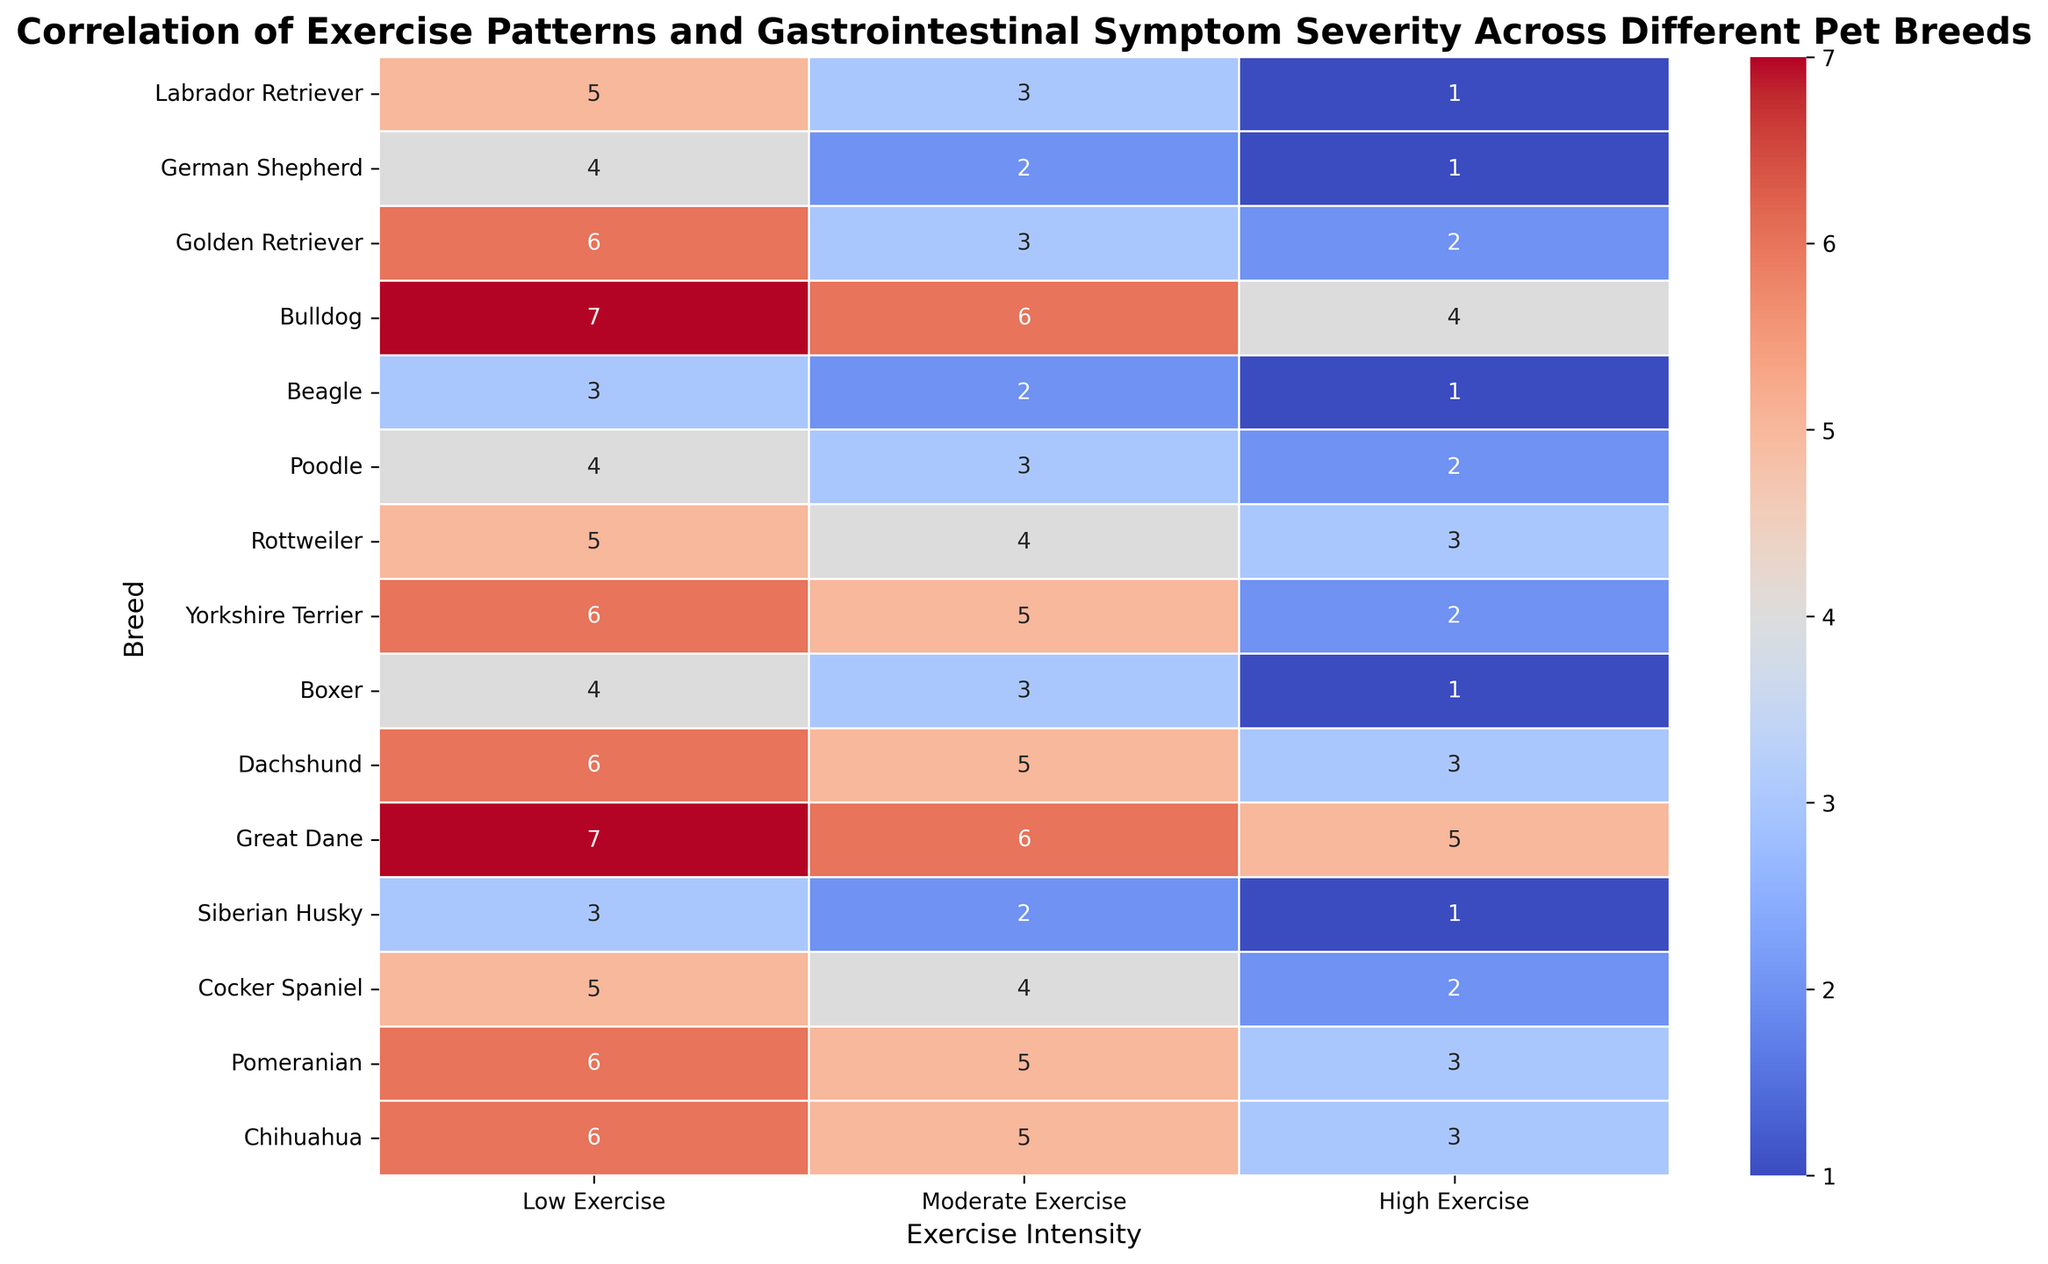What breed shows the highest severity of gastrointestinal symptoms in low exercise? In the heatmap, check the Low Exercise column. The breed with the highest value in this column is Bulldog with a value of 7.
Answer: Bulldog Which breed experiences the greatest reduction in symptoms from low to high exercise? Compute the differences for each breed: Labrador Retriever (5-1=4), German Shepherd (4-1=3), Golden Retriever (6-2=4), Bulldog (7-4=3), Beagle (3-1=2), Poodle (4-2=2), Rottweiler (5-3=2), Yorkshire Terrier (6-2=4), Boxer (4-1=3), Dachshund (6-3=3), Great Dane (7-5=2), Siberian Husky (3-1=2), Cocker Spaniel (5-2=3), Pomeranian (6-3=3), Chihuahua (6-3=3). The largest reduction is 4, which is seen in Labrador Retriever, Golden Retriever, and Yorkshire Terrier.
Answer: Labrador Retriever, Golden Retriever, Yorkshire Terrier What is the average severity of gastrointestinal symptoms for moderate exercise across all breeds? Add all the values in the Moderate Exercise column and divide by the number of breeds: (3 + 2 + 3 + 6 + 2 + 3 + 4 + 5 + 3 + 5 + 6 + 2 + 4 + 5 + 5) / 15 = 58 / 15 = 3.87.
Answer: 3.87 Which breed has a consistent symptom severity pattern across all exercise levels? Identify breeds with similar values across Low, Moderate, and High Exercise columns: Bulldog (7, 6, 4) shows varying levels. Beagle (3, 2, 1) demonstrates consistent decrement. Similarly, Siberian Husky (3, 2, 1) shows consistent decrement.
Answer: Beagle, Siberian Husky How many breeds show a symptom severity of 5 or more in low exercise? Count the breeds with values >= 5 in the Low Exercise column: Labrador Retriever, Golden Retriever, Bulldog, Yorkshire Terrier, Dachshund, Great Dane, Pomeranian, Chihuahua (8 breeds).
Answer: 8 Which exercise intensity shows the least severity of gastrointestinal symptoms for Great Dane? Check the values for Great Dane across different intensities: Low (7), Moderate (6), High (5). The least severity is in High Exercise (5).
Answer: High Exercise Compare the severity between Labrador Retriever and German Shepherd for high exercise. What do you observe? Check the High Exercise values: Labrador Retriever (1) and German Shepherd (1). Both have the same severity value of 1.
Answer: Equal, both 1 Which breed has a symptom severity of 2 in high exercise? Check the High Exercise column: Golden Retriever and Poodle both have a value of 2 in high exercise.
Answer: Golden Retriever, Poodle What is the median severity for low exercise across all breeds? Arrange the Low Exercise values in ascending order and find the median: (3, 3, 3, 4, 4, 4, 5, 5, 6, 6, 6, 6, 6, 7, 7). The middle value is the 8th value, which is 5.
Answer: 5 